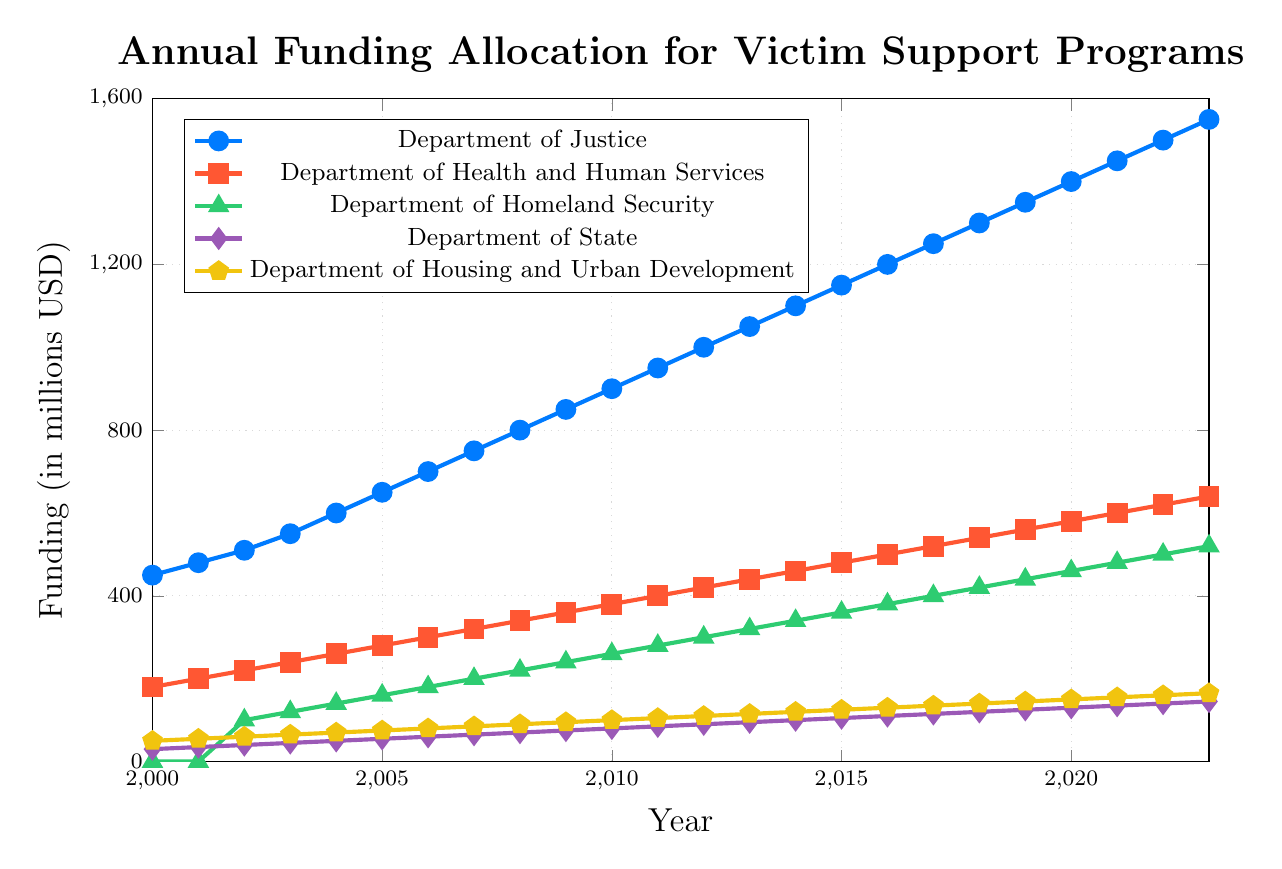What is the funding allocation for the Department of Justice in 2023? To find this information, look at the line representing the Department of Justice, then locate the funding value at the year 2023 on the x-axis.
Answer: 1550 Which department had zero funding in 2000 and when did its funding begin? Look for the line that starts at zero in 2000 and identify the earliest point where the line starts increasing.
Answer: Department of Homeland Security, 2002 What is the difference in funding between the Department of Health and Human Services and the Department of Housing and Urban Development in 2010? Look at the funding values for both departments in 2010. Subtract the value for the Department of Housing and Urban Development from that of the Department of Health and Human Services.
Answer: 280 Which department shows the greatest increase in funding from 2000 to 2023? To determine this, calculate the increase for each department by subtracting the 2000 value from the 2023 value and identify the greatest increase.
Answer: Department of Justice How does the funding trend for the Department of State compare to that of the Department of Housing and Urban Development over the years? Observe the trends of both lines by noting how they increase over time and compare their slopes and consistency.
Answer: Both have a gradual increasing trend, but the Department of Housing and Urban Development has a slightly steeper slope What year did the Department of Justice first receive more than 1000 million in funding? Look at the Department of Justice line and identify the first year where the funding exceeds 1000 million.
Answer: 2012 How many years did it take for the Department of Homeland Security to reach 500 million in funding from its first allocation? Find the first year of funding for the Department of Homeland Security (2002) and the year it reached 500 million (2022), then calculate the difference in years.
Answer: 21 years Which department received the least funding in 2005 and how much was it? Compare the funding values for all departments in 2005 and identify the smallest value.
Answer: Department of State, 55 million What is the average annual increase in funding for the Department of Health and Human Services from 2000 to 2023? Calculate the difference between the values in 2023 and 2000, then divide this by the number of years (2023-2000).
Answer: (640 - 180) / (2023 - 2000) = 20 million per year Is the funding pattern for each department mostly linear, or are there any noticeable fluctuations? Observe the trend lines for each department to determine if they increase steadily (linear) or have noticeable ups and downs (fluctuations).
Answer: Mostly linear 